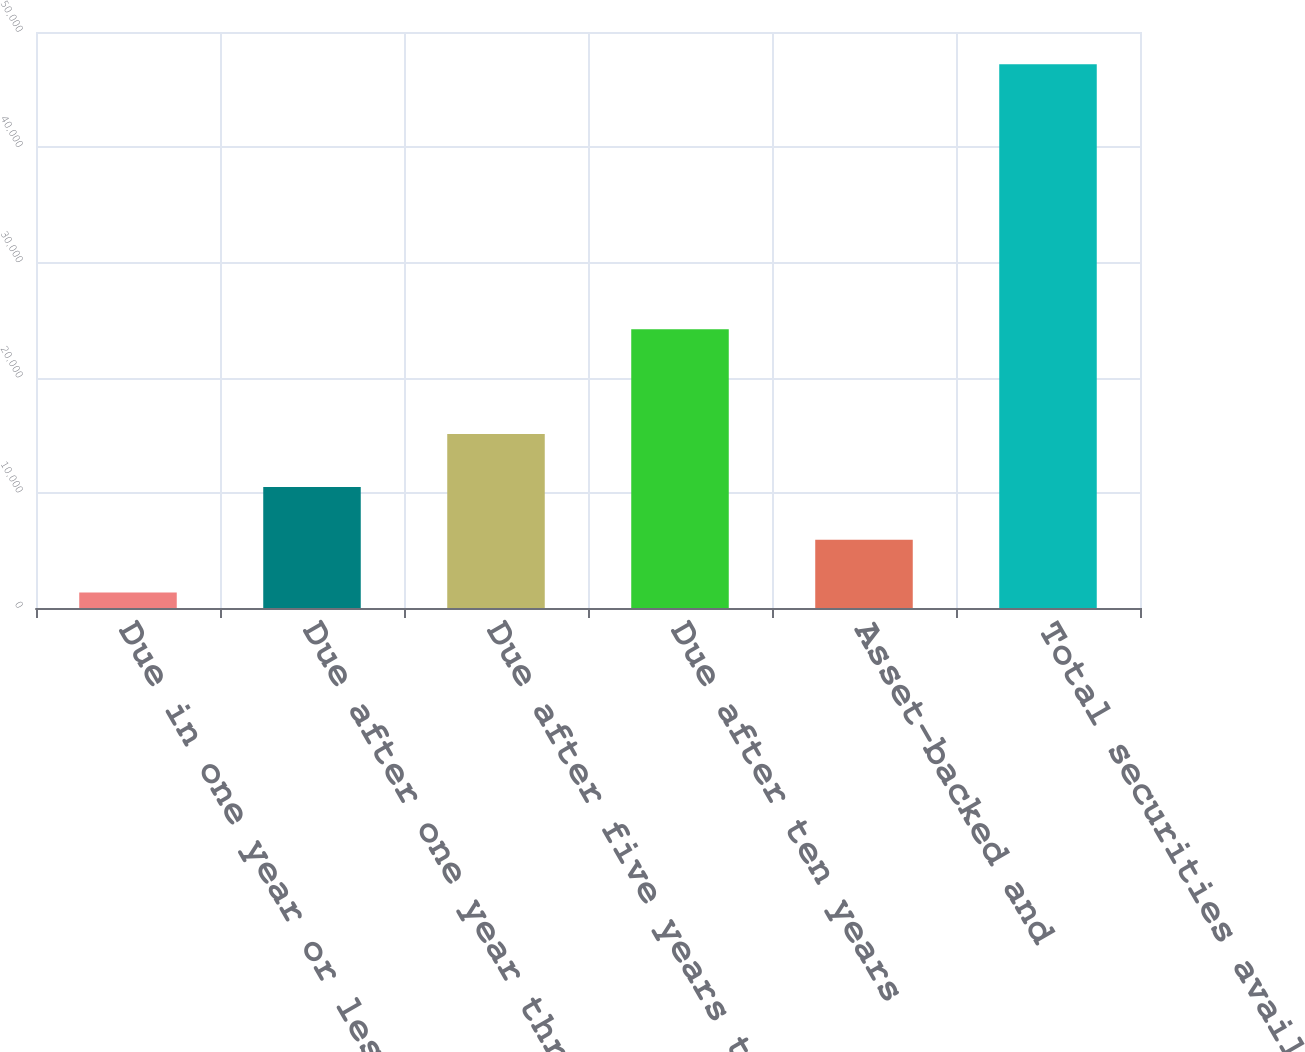Convert chart to OTSL. <chart><loc_0><loc_0><loc_500><loc_500><bar_chart><fcel>Due in one year or less<fcel>Due after one year through<fcel>Due after five years through<fcel>Due after ten years<fcel>Asset-backed and<fcel>Total securities available for<nl><fcel>1336<fcel>10509.8<fcel>15096.7<fcel>24204<fcel>5922.9<fcel>47205<nl></chart> 